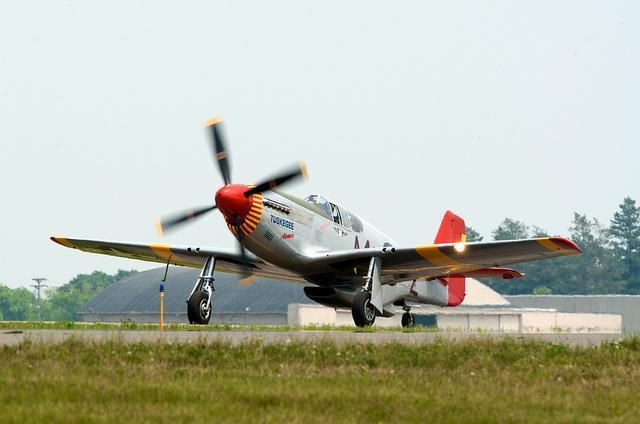How many birds are in the picture?
Give a very brief answer. 0. 